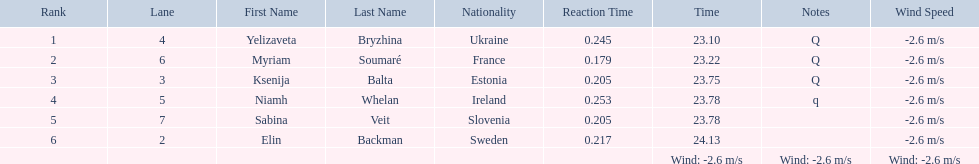What place did elin backman finish the race in? 6. How long did it take him to finish? 24.13. 